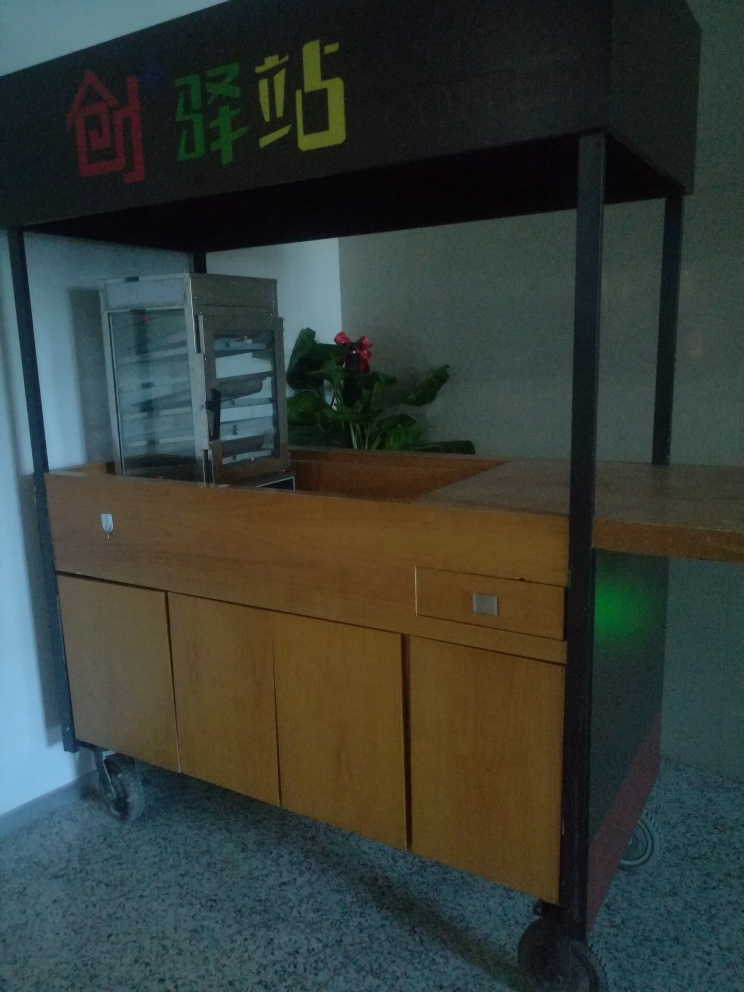What items can be seen on the counter and what does their presence suggest about this establishment? There's a clear food display case on the counter and a potted plant, which can often signify an attempt to create a pleasant and welcoming environment. The food display case suggests that the establishment serves ready-to-eat items, probably pastries or refrigerated delicacies. The presence of wheels on the counter suggests it may be a movable setup, which is convenient for cleaning or reconfiguration of the space. 